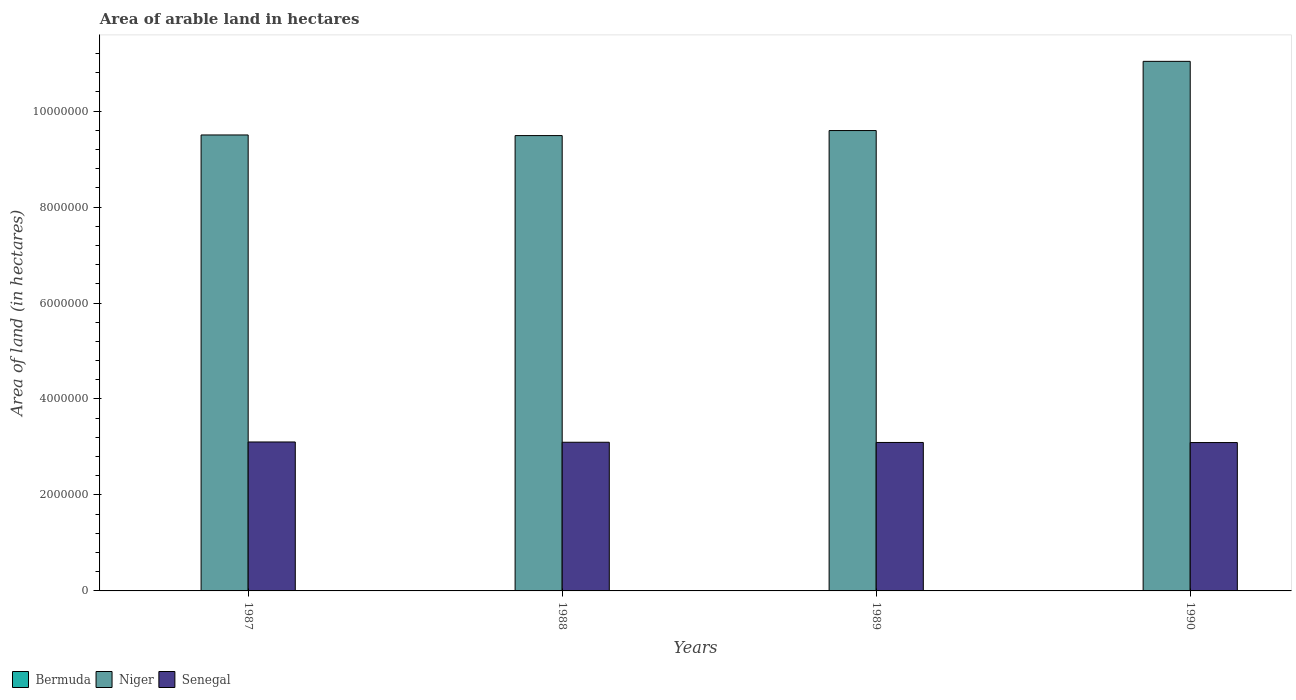How many groups of bars are there?
Your response must be concise. 4. What is the label of the 2nd group of bars from the left?
Offer a terse response. 1988. In how many cases, is the number of bars for a given year not equal to the number of legend labels?
Ensure brevity in your answer.  0. What is the total arable land in Bermuda in 1990?
Offer a very short reply. 300. Across all years, what is the maximum total arable land in Senegal?
Ensure brevity in your answer.  3.10e+06. Across all years, what is the minimum total arable land in Niger?
Your answer should be very brief. 9.49e+06. In which year was the total arable land in Niger minimum?
Offer a terse response. 1988. What is the total total arable land in Niger in the graph?
Ensure brevity in your answer.  3.96e+07. What is the difference between the total arable land in Senegal in 1987 and that in 1990?
Give a very brief answer. 1.20e+04. What is the difference between the total arable land in Senegal in 1987 and the total arable land in Bermuda in 1989?
Your answer should be compact. 3.10e+06. What is the average total arable land in Niger per year?
Provide a short and direct response. 9.91e+06. In the year 1988, what is the difference between the total arable land in Senegal and total arable land in Bermuda?
Give a very brief answer. 3.10e+06. In how many years, is the total arable land in Senegal greater than 10400000 hectares?
Give a very brief answer. 0. What is the ratio of the total arable land in Senegal in 1988 to that in 1990?
Provide a succinct answer. 1. Is the total arable land in Niger in 1989 less than that in 1990?
Give a very brief answer. Yes. Is the difference between the total arable land in Senegal in 1988 and 1989 greater than the difference between the total arable land in Bermuda in 1988 and 1989?
Ensure brevity in your answer.  Yes. What is the difference between the highest and the second highest total arable land in Bermuda?
Your answer should be very brief. 0. What is the difference between the highest and the lowest total arable land in Senegal?
Your answer should be very brief. 1.20e+04. In how many years, is the total arable land in Senegal greater than the average total arable land in Senegal taken over all years?
Give a very brief answer. 2. What does the 3rd bar from the left in 1989 represents?
Give a very brief answer. Senegal. What does the 3rd bar from the right in 1987 represents?
Provide a succinct answer. Bermuda. Does the graph contain any zero values?
Provide a short and direct response. No. Where does the legend appear in the graph?
Provide a succinct answer. Bottom left. How are the legend labels stacked?
Your answer should be very brief. Horizontal. What is the title of the graph?
Your answer should be very brief. Area of arable land in hectares. Does "Bahamas" appear as one of the legend labels in the graph?
Give a very brief answer. No. What is the label or title of the Y-axis?
Provide a succinct answer. Area of land (in hectares). What is the Area of land (in hectares) of Bermuda in 1987?
Your answer should be compact. 300. What is the Area of land (in hectares) of Niger in 1987?
Give a very brief answer. 9.50e+06. What is the Area of land (in hectares) of Senegal in 1987?
Make the answer very short. 3.10e+06. What is the Area of land (in hectares) of Bermuda in 1988?
Offer a terse response. 300. What is the Area of land (in hectares) in Niger in 1988?
Your response must be concise. 9.49e+06. What is the Area of land (in hectares) in Senegal in 1988?
Offer a very short reply. 3.10e+06. What is the Area of land (in hectares) of Bermuda in 1989?
Give a very brief answer. 300. What is the Area of land (in hectares) in Niger in 1989?
Offer a terse response. 9.59e+06. What is the Area of land (in hectares) in Senegal in 1989?
Ensure brevity in your answer.  3.09e+06. What is the Area of land (in hectares) of Bermuda in 1990?
Offer a very short reply. 300. What is the Area of land (in hectares) of Niger in 1990?
Offer a very short reply. 1.10e+07. What is the Area of land (in hectares) of Senegal in 1990?
Give a very brief answer. 3.09e+06. Across all years, what is the maximum Area of land (in hectares) in Bermuda?
Your response must be concise. 300. Across all years, what is the maximum Area of land (in hectares) in Niger?
Your response must be concise. 1.10e+07. Across all years, what is the maximum Area of land (in hectares) of Senegal?
Make the answer very short. 3.10e+06. Across all years, what is the minimum Area of land (in hectares) of Bermuda?
Give a very brief answer. 300. Across all years, what is the minimum Area of land (in hectares) in Niger?
Provide a short and direct response. 9.49e+06. Across all years, what is the minimum Area of land (in hectares) in Senegal?
Make the answer very short. 3.09e+06. What is the total Area of land (in hectares) in Bermuda in the graph?
Provide a short and direct response. 1200. What is the total Area of land (in hectares) of Niger in the graph?
Offer a very short reply. 3.96e+07. What is the total Area of land (in hectares) in Senegal in the graph?
Your answer should be very brief. 1.24e+07. What is the difference between the Area of land (in hectares) in Bermuda in 1987 and that in 1988?
Your answer should be compact. 0. What is the difference between the Area of land (in hectares) of Niger in 1987 and that in 1988?
Offer a very short reply. 1.30e+04. What is the difference between the Area of land (in hectares) in Senegal in 1987 and that in 1988?
Make the answer very short. 6000. What is the difference between the Area of land (in hectares) in Bermuda in 1987 and that in 1989?
Make the answer very short. 0. What is the difference between the Area of land (in hectares) of Niger in 1987 and that in 1989?
Keep it short and to the point. -9.20e+04. What is the difference between the Area of land (in hectares) in Senegal in 1987 and that in 1989?
Ensure brevity in your answer.  10000. What is the difference between the Area of land (in hectares) of Bermuda in 1987 and that in 1990?
Keep it short and to the point. 0. What is the difference between the Area of land (in hectares) of Niger in 1987 and that in 1990?
Your response must be concise. -1.53e+06. What is the difference between the Area of land (in hectares) of Senegal in 1987 and that in 1990?
Provide a short and direct response. 1.20e+04. What is the difference between the Area of land (in hectares) of Niger in 1988 and that in 1989?
Your answer should be compact. -1.05e+05. What is the difference between the Area of land (in hectares) in Senegal in 1988 and that in 1989?
Offer a very short reply. 4000. What is the difference between the Area of land (in hectares) in Niger in 1988 and that in 1990?
Your answer should be compact. -1.55e+06. What is the difference between the Area of land (in hectares) of Senegal in 1988 and that in 1990?
Provide a short and direct response. 6000. What is the difference between the Area of land (in hectares) of Niger in 1989 and that in 1990?
Your answer should be very brief. -1.44e+06. What is the difference between the Area of land (in hectares) of Bermuda in 1987 and the Area of land (in hectares) of Niger in 1988?
Your answer should be compact. -9.49e+06. What is the difference between the Area of land (in hectares) of Bermuda in 1987 and the Area of land (in hectares) of Senegal in 1988?
Provide a succinct answer. -3.10e+06. What is the difference between the Area of land (in hectares) of Niger in 1987 and the Area of land (in hectares) of Senegal in 1988?
Provide a short and direct response. 6.40e+06. What is the difference between the Area of land (in hectares) of Bermuda in 1987 and the Area of land (in hectares) of Niger in 1989?
Your answer should be compact. -9.59e+06. What is the difference between the Area of land (in hectares) in Bermuda in 1987 and the Area of land (in hectares) in Senegal in 1989?
Provide a short and direct response. -3.09e+06. What is the difference between the Area of land (in hectares) in Niger in 1987 and the Area of land (in hectares) in Senegal in 1989?
Your answer should be compact. 6.41e+06. What is the difference between the Area of land (in hectares) in Bermuda in 1987 and the Area of land (in hectares) in Niger in 1990?
Offer a very short reply. -1.10e+07. What is the difference between the Area of land (in hectares) of Bermuda in 1987 and the Area of land (in hectares) of Senegal in 1990?
Provide a short and direct response. -3.09e+06. What is the difference between the Area of land (in hectares) in Niger in 1987 and the Area of land (in hectares) in Senegal in 1990?
Ensure brevity in your answer.  6.41e+06. What is the difference between the Area of land (in hectares) of Bermuda in 1988 and the Area of land (in hectares) of Niger in 1989?
Keep it short and to the point. -9.59e+06. What is the difference between the Area of land (in hectares) in Bermuda in 1988 and the Area of land (in hectares) in Senegal in 1989?
Make the answer very short. -3.09e+06. What is the difference between the Area of land (in hectares) in Niger in 1988 and the Area of land (in hectares) in Senegal in 1989?
Your answer should be compact. 6.40e+06. What is the difference between the Area of land (in hectares) of Bermuda in 1988 and the Area of land (in hectares) of Niger in 1990?
Give a very brief answer. -1.10e+07. What is the difference between the Area of land (in hectares) in Bermuda in 1988 and the Area of land (in hectares) in Senegal in 1990?
Keep it short and to the point. -3.09e+06. What is the difference between the Area of land (in hectares) of Niger in 1988 and the Area of land (in hectares) of Senegal in 1990?
Ensure brevity in your answer.  6.40e+06. What is the difference between the Area of land (in hectares) of Bermuda in 1989 and the Area of land (in hectares) of Niger in 1990?
Provide a succinct answer. -1.10e+07. What is the difference between the Area of land (in hectares) of Bermuda in 1989 and the Area of land (in hectares) of Senegal in 1990?
Your response must be concise. -3.09e+06. What is the difference between the Area of land (in hectares) in Niger in 1989 and the Area of land (in hectares) in Senegal in 1990?
Ensure brevity in your answer.  6.50e+06. What is the average Area of land (in hectares) of Bermuda per year?
Your response must be concise. 300. What is the average Area of land (in hectares) in Niger per year?
Your answer should be compact. 9.91e+06. What is the average Area of land (in hectares) of Senegal per year?
Keep it short and to the point. 3.10e+06. In the year 1987, what is the difference between the Area of land (in hectares) of Bermuda and Area of land (in hectares) of Niger?
Make the answer very short. -9.50e+06. In the year 1987, what is the difference between the Area of land (in hectares) in Bermuda and Area of land (in hectares) in Senegal?
Make the answer very short. -3.10e+06. In the year 1987, what is the difference between the Area of land (in hectares) in Niger and Area of land (in hectares) in Senegal?
Offer a very short reply. 6.40e+06. In the year 1988, what is the difference between the Area of land (in hectares) in Bermuda and Area of land (in hectares) in Niger?
Your answer should be very brief. -9.49e+06. In the year 1988, what is the difference between the Area of land (in hectares) in Bermuda and Area of land (in hectares) in Senegal?
Provide a short and direct response. -3.10e+06. In the year 1988, what is the difference between the Area of land (in hectares) of Niger and Area of land (in hectares) of Senegal?
Ensure brevity in your answer.  6.39e+06. In the year 1989, what is the difference between the Area of land (in hectares) in Bermuda and Area of land (in hectares) in Niger?
Your answer should be very brief. -9.59e+06. In the year 1989, what is the difference between the Area of land (in hectares) in Bermuda and Area of land (in hectares) in Senegal?
Your answer should be very brief. -3.09e+06. In the year 1989, what is the difference between the Area of land (in hectares) of Niger and Area of land (in hectares) of Senegal?
Offer a very short reply. 6.50e+06. In the year 1990, what is the difference between the Area of land (in hectares) in Bermuda and Area of land (in hectares) in Niger?
Offer a very short reply. -1.10e+07. In the year 1990, what is the difference between the Area of land (in hectares) in Bermuda and Area of land (in hectares) in Senegal?
Make the answer very short. -3.09e+06. In the year 1990, what is the difference between the Area of land (in hectares) in Niger and Area of land (in hectares) in Senegal?
Make the answer very short. 7.94e+06. What is the ratio of the Area of land (in hectares) in Bermuda in 1987 to that in 1988?
Your answer should be compact. 1. What is the ratio of the Area of land (in hectares) in Niger in 1987 to that in 1988?
Give a very brief answer. 1. What is the ratio of the Area of land (in hectares) in Bermuda in 1987 to that in 1989?
Your answer should be compact. 1. What is the ratio of the Area of land (in hectares) of Bermuda in 1987 to that in 1990?
Your answer should be very brief. 1. What is the ratio of the Area of land (in hectares) in Niger in 1987 to that in 1990?
Offer a very short reply. 0.86. What is the ratio of the Area of land (in hectares) of Bermuda in 1988 to that in 1989?
Your answer should be compact. 1. What is the ratio of the Area of land (in hectares) of Niger in 1988 to that in 1990?
Your response must be concise. 0.86. What is the ratio of the Area of land (in hectares) in Bermuda in 1989 to that in 1990?
Make the answer very short. 1. What is the ratio of the Area of land (in hectares) of Niger in 1989 to that in 1990?
Make the answer very short. 0.87. What is the ratio of the Area of land (in hectares) of Senegal in 1989 to that in 1990?
Provide a succinct answer. 1. What is the difference between the highest and the second highest Area of land (in hectares) of Niger?
Make the answer very short. 1.44e+06. What is the difference between the highest and the second highest Area of land (in hectares) of Senegal?
Provide a succinct answer. 6000. What is the difference between the highest and the lowest Area of land (in hectares) in Niger?
Your response must be concise. 1.55e+06. What is the difference between the highest and the lowest Area of land (in hectares) in Senegal?
Your response must be concise. 1.20e+04. 